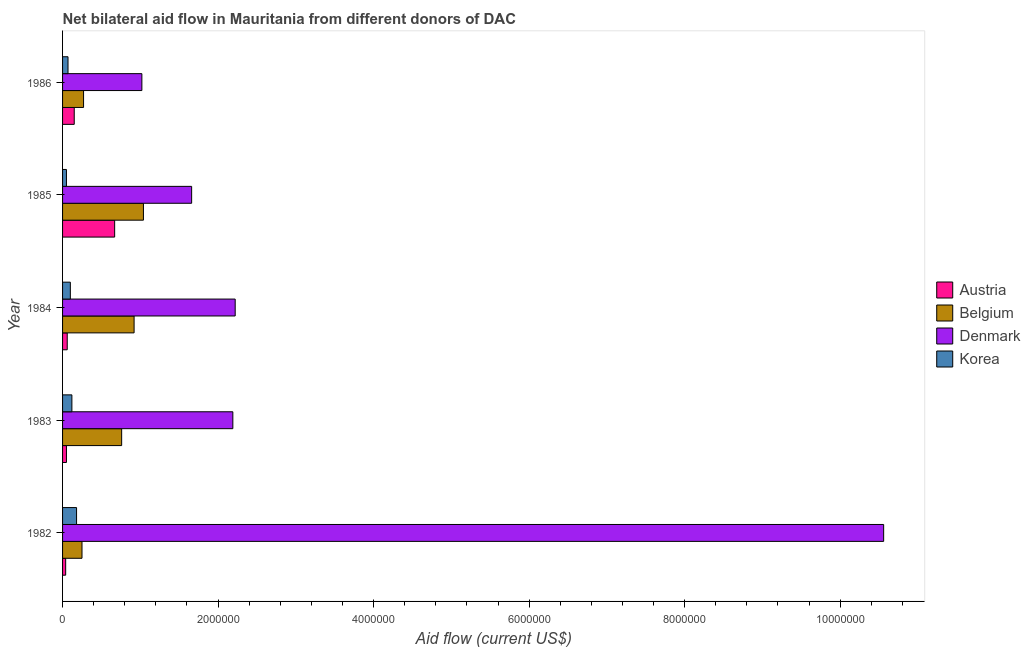Are the number of bars on each tick of the Y-axis equal?
Provide a succinct answer. Yes. How many bars are there on the 4th tick from the bottom?
Make the answer very short. 4. In how many cases, is the number of bars for a given year not equal to the number of legend labels?
Offer a very short reply. 0. What is the amount of aid given by denmark in 1984?
Offer a terse response. 2.22e+06. Across all years, what is the maximum amount of aid given by belgium?
Offer a terse response. 1.04e+06. Across all years, what is the minimum amount of aid given by belgium?
Keep it short and to the point. 2.50e+05. What is the total amount of aid given by denmark in the graph?
Ensure brevity in your answer.  1.76e+07. What is the difference between the amount of aid given by korea in 1984 and that in 1986?
Offer a very short reply. 3.00e+04. What is the difference between the amount of aid given by austria in 1984 and the amount of aid given by korea in 1986?
Provide a succinct answer. -10000. What is the average amount of aid given by denmark per year?
Your response must be concise. 3.53e+06. In the year 1983, what is the difference between the amount of aid given by korea and amount of aid given by denmark?
Provide a succinct answer. -2.07e+06. What is the ratio of the amount of aid given by denmark in 1985 to that in 1986?
Give a very brief answer. 1.63. Is the difference between the amount of aid given by belgium in 1985 and 1986 greater than the difference between the amount of aid given by austria in 1985 and 1986?
Provide a short and direct response. Yes. What is the difference between the highest and the second highest amount of aid given by denmark?
Ensure brevity in your answer.  8.34e+06. What is the difference between the highest and the lowest amount of aid given by denmark?
Make the answer very short. 9.54e+06. In how many years, is the amount of aid given by denmark greater than the average amount of aid given by denmark taken over all years?
Offer a very short reply. 1. Is the sum of the amount of aid given by denmark in 1984 and 1986 greater than the maximum amount of aid given by korea across all years?
Offer a very short reply. Yes. Is it the case that in every year, the sum of the amount of aid given by denmark and amount of aid given by belgium is greater than the sum of amount of aid given by korea and amount of aid given by austria?
Make the answer very short. Yes. What does the 4th bar from the top in 1983 represents?
Offer a very short reply. Austria. Is it the case that in every year, the sum of the amount of aid given by austria and amount of aid given by belgium is greater than the amount of aid given by denmark?
Keep it short and to the point. No. Are all the bars in the graph horizontal?
Your answer should be compact. Yes. Does the graph contain grids?
Your response must be concise. No. Where does the legend appear in the graph?
Your answer should be compact. Center right. How are the legend labels stacked?
Provide a short and direct response. Vertical. What is the title of the graph?
Your response must be concise. Net bilateral aid flow in Mauritania from different donors of DAC. What is the label or title of the Y-axis?
Your response must be concise. Year. What is the Aid flow (current US$) of Austria in 1982?
Ensure brevity in your answer.  4.00e+04. What is the Aid flow (current US$) of Belgium in 1982?
Offer a very short reply. 2.50e+05. What is the Aid flow (current US$) in Denmark in 1982?
Keep it short and to the point. 1.06e+07. What is the Aid flow (current US$) in Korea in 1982?
Provide a succinct answer. 1.80e+05. What is the Aid flow (current US$) in Belgium in 1983?
Give a very brief answer. 7.60e+05. What is the Aid flow (current US$) in Denmark in 1983?
Offer a very short reply. 2.19e+06. What is the Aid flow (current US$) in Korea in 1983?
Provide a short and direct response. 1.20e+05. What is the Aid flow (current US$) in Belgium in 1984?
Keep it short and to the point. 9.20e+05. What is the Aid flow (current US$) of Denmark in 1984?
Give a very brief answer. 2.22e+06. What is the Aid flow (current US$) in Austria in 1985?
Keep it short and to the point. 6.70e+05. What is the Aid flow (current US$) in Belgium in 1985?
Provide a short and direct response. 1.04e+06. What is the Aid flow (current US$) in Denmark in 1985?
Your answer should be very brief. 1.66e+06. What is the Aid flow (current US$) of Korea in 1985?
Your answer should be compact. 5.00e+04. What is the Aid flow (current US$) in Denmark in 1986?
Give a very brief answer. 1.02e+06. What is the Aid flow (current US$) in Korea in 1986?
Provide a succinct answer. 7.00e+04. Across all years, what is the maximum Aid flow (current US$) of Austria?
Your response must be concise. 6.70e+05. Across all years, what is the maximum Aid flow (current US$) of Belgium?
Your answer should be compact. 1.04e+06. Across all years, what is the maximum Aid flow (current US$) in Denmark?
Your answer should be very brief. 1.06e+07. Across all years, what is the maximum Aid flow (current US$) in Korea?
Offer a terse response. 1.80e+05. Across all years, what is the minimum Aid flow (current US$) in Belgium?
Offer a very short reply. 2.50e+05. Across all years, what is the minimum Aid flow (current US$) of Denmark?
Your answer should be compact. 1.02e+06. Across all years, what is the minimum Aid flow (current US$) of Korea?
Offer a very short reply. 5.00e+04. What is the total Aid flow (current US$) in Austria in the graph?
Provide a succinct answer. 9.70e+05. What is the total Aid flow (current US$) of Belgium in the graph?
Offer a very short reply. 3.24e+06. What is the total Aid flow (current US$) in Denmark in the graph?
Provide a short and direct response. 1.76e+07. What is the total Aid flow (current US$) of Korea in the graph?
Provide a succinct answer. 5.20e+05. What is the difference between the Aid flow (current US$) in Belgium in 1982 and that in 1983?
Give a very brief answer. -5.10e+05. What is the difference between the Aid flow (current US$) in Denmark in 1982 and that in 1983?
Provide a short and direct response. 8.37e+06. What is the difference between the Aid flow (current US$) in Korea in 1982 and that in 1983?
Give a very brief answer. 6.00e+04. What is the difference between the Aid flow (current US$) of Belgium in 1982 and that in 1984?
Keep it short and to the point. -6.70e+05. What is the difference between the Aid flow (current US$) in Denmark in 1982 and that in 1984?
Provide a short and direct response. 8.34e+06. What is the difference between the Aid flow (current US$) of Korea in 1982 and that in 1984?
Your answer should be compact. 8.00e+04. What is the difference between the Aid flow (current US$) in Austria in 1982 and that in 1985?
Keep it short and to the point. -6.30e+05. What is the difference between the Aid flow (current US$) in Belgium in 1982 and that in 1985?
Provide a short and direct response. -7.90e+05. What is the difference between the Aid flow (current US$) in Denmark in 1982 and that in 1985?
Offer a very short reply. 8.90e+06. What is the difference between the Aid flow (current US$) in Korea in 1982 and that in 1985?
Ensure brevity in your answer.  1.30e+05. What is the difference between the Aid flow (current US$) in Austria in 1982 and that in 1986?
Give a very brief answer. -1.10e+05. What is the difference between the Aid flow (current US$) of Denmark in 1982 and that in 1986?
Your answer should be very brief. 9.54e+06. What is the difference between the Aid flow (current US$) of Korea in 1982 and that in 1986?
Your answer should be very brief. 1.10e+05. What is the difference between the Aid flow (current US$) of Denmark in 1983 and that in 1984?
Provide a succinct answer. -3.00e+04. What is the difference between the Aid flow (current US$) in Austria in 1983 and that in 1985?
Provide a short and direct response. -6.20e+05. What is the difference between the Aid flow (current US$) in Belgium in 1983 and that in 1985?
Offer a terse response. -2.80e+05. What is the difference between the Aid flow (current US$) of Denmark in 1983 and that in 1985?
Your answer should be compact. 5.30e+05. What is the difference between the Aid flow (current US$) of Belgium in 1983 and that in 1986?
Your answer should be very brief. 4.90e+05. What is the difference between the Aid flow (current US$) in Denmark in 1983 and that in 1986?
Offer a very short reply. 1.17e+06. What is the difference between the Aid flow (current US$) in Austria in 1984 and that in 1985?
Give a very brief answer. -6.10e+05. What is the difference between the Aid flow (current US$) of Denmark in 1984 and that in 1985?
Your response must be concise. 5.60e+05. What is the difference between the Aid flow (current US$) of Austria in 1984 and that in 1986?
Your response must be concise. -9.00e+04. What is the difference between the Aid flow (current US$) of Belgium in 1984 and that in 1986?
Your answer should be compact. 6.50e+05. What is the difference between the Aid flow (current US$) in Denmark in 1984 and that in 1986?
Provide a short and direct response. 1.20e+06. What is the difference between the Aid flow (current US$) of Korea in 1984 and that in 1986?
Make the answer very short. 3.00e+04. What is the difference between the Aid flow (current US$) of Austria in 1985 and that in 1986?
Provide a succinct answer. 5.20e+05. What is the difference between the Aid flow (current US$) in Belgium in 1985 and that in 1986?
Make the answer very short. 7.70e+05. What is the difference between the Aid flow (current US$) in Denmark in 1985 and that in 1986?
Offer a very short reply. 6.40e+05. What is the difference between the Aid flow (current US$) of Korea in 1985 and that in 1986?
Your answer should be compact. -2.00e+04. What is the difference between the Aid flow (current US$) in Austria in 1982 and the Aid flow (current US$) in Belgium in 1983?
Your answer should be compact. -7.20e+05. What is the difference between the Aid flow (current US$) of Austria in 1982 and the Aid flow (current US$) of Denmark in 1983?
Offer a very short reply. -2.15e+06. What is the difference between the Aid flow (current US$) in Austria in 1982 and the Aid flow (current US$) in Korea in 1983?
Ensure brevity in your answer.  -8.00e+04. What is the difference between the Aid flow (current US$) of Belgium in 1982 and the Aid flow (current US$) of Denmark in 1983?
Keep it short and to the point. -1.94e+06. What is the difference between the Aid flow (current US$) in Belgium in 1982 and the Aid flow (current US$) in Korea in 1983?
Ensure brevity in your answer.  1.30e+05. What is the difference between the Aid flow (current US$) of Denmark in 1982 and the Aid flow (current US$) of Korea in 1983?
Ensure brevity in your answer.  1.04e+07. What is the difference between the Aid flow (current US$) in Austria in 1982 and the Aid flow (current US$) in Belgium in 1984?
Your answer should be compact. -8.80e+05. What is the difference between the Aid flow (current US$) in Austria in 1982 and the Aid flow (current US$) in Denmark in 1984?
Your answer should be very brief. -2.18e+06. What is the difference between the Aid flow (current US$) of Austria in 1982 and the Aid flow (current US$) of Korea in 1984?
Make the answer very short. -6.00e+04. What is the difference between the Aid flow (current US$) in Belgium in 1982 and the Aid flow (current US$) in Denmark in 1984?
Your response must be concise. -1.97e+06. What is the difference between the Aid flow (current US$) in Belgium in 1982 and the Aid flow (current US$) in Korea in 1984?
Provide a short and direct response. 1.50e+05. What is the difference between the Aid flow (current US$) of Denmark in 1982 and the Aid flow (current US$) of Korea in 1984?
Ensure brevity in your answer.  1.05e+07. What is the difference between the Aid flow (current US$) in Austria in 1982 and the Aid flow (current US$) in Denmark in 1985?
Give a very brief answer. -1.62e+06. What is the difference between the Aid flow (current US$) in Austria in 1982 and the Aid flow (current US$) in Korea in 1985?
Provide a succinct answer. -10000. What is the difference between the Aid flow (current US$) of Belgium in 1982 and the Aid flow (current US$) of Denmark in 1985?
Your answer should be very brief. -1.41e+06. What is the difference between the Aid flow (current US$) of Denmark in 1982 and the Aid flow (current US$) of Korea in 1985?
Your answer should be very brief. 1.05e+07. What is the difference between the Aid flow (current US$) in Austria in 1982 and the Aid flow (current US$) in Denmark in 1986?
Keep it short and to the point. -9.80e+05. What is the difference between the Aid flow (current US$) of Austria in 1982 and the Aid flow (current US$) of Korea in 1986?
Your answer should be compact. -3.00e+04. What is the difference between the Aid flow (current US$) in Belgium in 1982 and the Aid flow (current US$) in Denmark in 1986?
Give a very brief answer. -7.70e+05. What is the difference between the Aid flow (current US$) in Denmark in 1982 and the Aid flow (current US$) in Korea in 1986?
Provide a short and direct response. 1.05e+07. What is the difference between the Aid flow (current US$) of Austria in 1983 and the Aid flow (current US$) of Belgium in 1984?
Keep it short and to the point. -8.70e+05. What is the difference between the Aid flow (current US$) of Austria in 1983 and the Aid flow (current US$) of Denmark in 1984?
Your answer should be very brief. -2.17e+06. What is the difference between the Aid flow (current US$) of Belgium in 1983 and the Aid flow (current US$) of Denmark in 1984?
Offer a very short reply. -1.46e+06. What is the difference between the Aid flow (current US$) of Belgium in 1983 and the Aid flow (current US$) of Korea in 1984?
Your answer should be compact. 6.60e+05. What is the difference between the Aid flow (current US$) in Denmark in 1983 and the Aid flow (current US$) in Korea in 1984?
Your answer should be very brief. 2.09e+06. What is the difference between the Aid flow (current US$) of Austria in 1983 and the Aid flow (current US$) of Belgium in 1985?
Your response must be concise. -9.90e+05. What is the difference between the Aid flow (current US$) in Austria in 1983 and the Aid flow (current US$) in Denmark in 1985?
Offer a very short reply. -1.61e+06. What is the difference between the Aid flow (current US$) of Austria in 1983 and the Aid flow (current US$) of Korea in 1985?
Your response must be concise. 0. What is the difference between the Aid flow (current US$) of Belgium in 1983 and the Aid flow (current US$) of Denmark in 1985?
Give a very brief answer. -9.00e+05. What is the difference between the Aid flow (current US$) of Belgium in 1983 and the Aid flow (current US$) of Korea in 1985?
Keep it short and to the point. 7.10e+05. What is the difference between the Aid flow (current US$) in Denmark in 1983 and the Aid flow (current US$) in Korea in 1985?
Provide a succinct answer. 2.14e+06. What is the difference between the Aid flow (current US$) of Austria in 1983 and the Aid flow (current US$) of Denmark in 1986?
Provide a succinct answer. -9.70e+05. What is the difference between the Aid flow (current US$) of Belgium in 1983 and the Aid flow (current US$) of Korea in 1986?
Your answer should be very brief. 6.90e+05. What is the difference between the Aid flow (current US$) of Denmark in 1983 and the Aid flow (current US$) of Korea in 1986?
Ensure brevity in your answer.  2.12e+06. What is the difference between the Aid flow (current US$) of Austria in 1984 and the Aid flow (current US$) of Belgium in 1985?
Ensure brevity in your answer.  -9.80e+05. What is the difference between the Aid flow (current US$) in Austria in 1984 and the Aid flow (current US$) in Denmark in 1985?
Make the answer very short. -1.60e+06. What is the difference between the Aid flow (current US$) of Belgium in 1984 and the Aid flow (current US$) of Denmark in 1985?
Offer a terse response. -7.40e+05. What is the difference between the Aid flow (current US$) in Belgium in 1984 and the Aid flow (current US$) in Korea in 1985?
Offer a terse response. 8.70e+05. What is the difference between the Aid flow (current US$) of Denmark in 1984 and the Aid flow (current US$) of Korea in 1985?
Your answer should be very brief. 2.17e+06. What is the difference between the Aid flow (current US$) of Austria in 1984 and the Aid flow (current US$) of Belgium in 1986?
Provide a short and direct response. -2.10e+05. What is the difference between the Aid flow (current US$) in Austria in 1984 and the Aid flow (current US$) in Denmark in 1986?
Your answer should be very brief. -9.60e+05. What is the difference between the Aid flow (current US$) in Belgium in 1984 and the Aid flow (current US$) in Korea in 1986?
Your response must be concise. 8.50e+05. What is the difference between the Aid flow (current US$) in Denmark in 1984 and the Aid flow (current US$) in Korea in 1986?
Offer a very short reply. 2.15e+06. What is the difference between the Aid flow (current US$) in Austria in 1985 and the Aid flow (current US$) in Belgium in 1986?
Offer a very short reply. 4.00e+05. What is the difference between the Aid flow (current US$) in Austria in 1985 and the Aid flow (current US$) in Denmark in 1986?
Provide a succinct answer. -3.50e+05. What is the difference between the Aid flow (current US$) in Belgium in 1985 and the Aid flow (current US$) in Denmark in 1986?
Make the answer very short. 2.00e+04. What is the difference between the Aid flow (current US$) of Belgium in 1985 and the Aid flow (current US$) of Korea in 1986?
Make the answer very short. 9.70e+05. What is the difference between the Aid flow (current US$) in Denmark in 1985 and the Aid flow (current US$) in Korea in 1986?
Provide a short and direct response. 1.59e+06. What is the average Aid flow (current US$) in Austria per year?
Keep it short and to the point. 1.94e+05. What is the average Aid flow (current US$) of Belgium per year?
Your response must be concise. 6.48e+05. What is the average Aid flow (current US$) in Denmark per year?
Provide a succinct answer. 3.53e+06. What is the average Aid flow (current US$) of Korea per year?
Make the answer very short. 1.04e+05. In the year 1982, what is the difference between the Aid flow (current US$) of Austria and Aid flow (current US$) of Belgium?
Give a very brief answer. -2.10e+05. In the year 1982, what is the difference between the Aid flow (current US$) of Austria and Aid flow (current US$) of Denmark?
Make the answer very short. -1.05e+07. In the year 1982, what is the difference between the Aid flow (current US$) in Belgium and Aid flow (current US$) in Denmark?
Your answer should be compact. -1.03e+07. In the year 1982, what is the difference between the Aid flow (current US$) of Belgium and Aid flow (current US$) of Korea?
Your answer should be very brief. 7.00e+04. In the year 1982, what is the difference between the Aid flow (current US$) in Denmark and Aid flow (current US$) in Korea?
Provide a short and direct response. 1.04e+07. In the year 1983, what is the difference between the Aid flow (current US$) of Austria and Aid flow (current US$) of Belgium?
Ensure brevity in your answer.  -7.10e+05. In the year 1983, what is the difference between the Aid flow (current US$) of Austria and Aid flow (current US$) of Denmark?
Make the answer very short. -2.14e+06. In the year 1983, what is the difference between the Aid flow (current US$) in Belgium and Aid flow (current US$) in Denmark?
Make the answer very short. -1.43e+06. In the year 1983, what is the difference between the Aid flow (current US$) in Belgium and Aid flow (current US$) in Korea?
Offer a very short reply. 6.40e+05. In the year 1983, what is the difference between the Aid flow (current US$) of Denmark and Aid flow (current US$) of Korea?
Provide a succinct answer. 2.07e+06. In the year 1984, what is the difference between the Aid flow (current US$) in Austria and Aid flow (current US$) in Belgium?
Your answer should be compact. -8.60e+05. In the year 1984, what is the difference between the Aid flow (current US$) of Austria and Aid flow (current US$) of Denmark?
Your response must be concise. -2.16e+06. In the year 1984, what is the difference between the Aid flow (current US$) of Belgium and Aid flow (current US$) of Denmark?
Provide a succinct answer. -1.30e+06. In the year 1984, what is the difference between the Aid flow (current US$) of Belgium and Aid flow (current US$) of Korea?
Your answer should be very brief. 8.20e+05. In the year 1984, what is the difference between the Aid flow (current US$) in Denmark and Aid flow (current US$) in Korea?
Your response must be concise. 2.12e+06. In the year 1985, what is the difference between the Aid flow (current US$) in Austria and Aid flow (current US$) in Belgium?
Ensure brevity in your answer.  -3.70e+05. In the year 1985, what is the difference between the Aid flow (current US$) in Austria and Aid flow (current US$) in Denmark?
Ensure brevity in your answer.  -9.90e+05. In the year 1985, what is the difference between the Aid flow (current US$) of Austria and Aid flow (current US$) of Korea?
Ensure brevity in your answer.  6.20e+05. In the year 1985, what is the difference between the Aid flow (current US$) of Belgium and Aid flow (current US$) of Denmark?
Your response must be concise. -6.20e+05. In the year 1985, what is the difference between the Aid flow (current US$) of Belgium and Aid flow (current US$) of Korea?
Your response must be concise. 9.90e+05. In the year 1985, what is the difference between the Aid flow (current US$) of Denmark and Aid flow (current US$) of Korea?
Keep it short and to the point. 1.61e+06. In the year 1986, what is the difference between the Aid flow (current US$) of Austria and Aid flow (current US$) of Denmark?
Provide a short and direct response. -8.70e+05. In the year 1986, what is the difference between the Aid flow (current US$) of Austria and Aid flow (current US$) of Korea?
Make the answer very short. 8.00e+04. In the year 1986, what is the difference between the Aid flow (current US$) of Belgium and Aid flow (current US$) of Denmark?
Your answer should be very brief. -7.50e+05. In the year 1986, what is the difference between the Aid flow (current US$) in Belgium and Aid flow (current US$) in Korea?
Make the answer very short. 2.00e+05. In the year 1986, what is the difference between the Aid flow (current US$) in Denmark and Aid flow (current US$) in Korea?
Make the answer very short. 9.50e+05. What is the ratio of the Aid flow (current US$) in Austria in 1982 to that in 1983?
Make the answer very short. 0.8. What is the ratio of the Aid flow (current US$) in Belgium in 1982 to that in 1983?
Your answer should be very brief. 0.33. What is the ratio of the Aid flow (current US$) in Denmark in 1982 to that in 1983?
Your answer should be very brief. 4.82. What is the ratio of the Aid flow (current US$) in Austria in 1982 to that in 1984?
Offer a terse response. 0.67. What is the ratio of the Aid flow (current US$) of Belgium in 1982 to that in 1984?
Provide a succinct answer. 0.27. What is the ratio of the Aid flow (current US$) in Denmark in 1982 to that in 1984?
Make the answer very short. 4.76. What is the ratio of the Aid flow (current US$) in Korea in 1982 to that in 1984?
Provide a succinct answer. 1.8. What is the ratio of the Aid flow (current US$) of Austria in 1982 to that in 1985?
Your answer should be very brief. 0.06. What is the ratio of the Aid flow (current US$) in Belgium in 1982 to that in 1985?
Offer a very short reply. 0.24. What is the ratio of the Aid flow (current US$) in Denmark in 1982 to that in 1985?
Your response must be concise. 6.36. What is the ratio of the Aid flow (current US$) of Korea in 1982 to that in 1985?
Ensure brevity in your answer.  3.6. What is the ratio of the Aid flow (current US$) in Austria in 1982 to that in 1986?
Your response must be concise. 0.27. What is the ratio of the Aid flow (current US$) of Belgium in 1982 to that in 1986?
Make the answer very short. 0.93. What is the ratio of the Aid flow (current US$) in Denmark in 1982 to that in 1986?
Your answer should be very brief. 10.35. What is the ratio of the Aid flow (current US$) of Korea in 1982 to that in 1986?
Offer a terse response. 2.57. What is the ratio of the Aid flow (current US$) in Austria in 1983 to that in 1984?
Provide a succinct answer. 0.83. What is the ratio of the Aid flow (current US$) of Belgium in 1983 to that in 1984?
Provide a short and direct response. 0.83. What is the ratio of the Aid flow (current US$) of Denmark in 1983 to that in 1984?
Make the answer very short. 0.99. What is the ratio of the Aid flow (current US$) in Korea in 1983 to that in 1984?
Keep it short and to the point. 1.2. What is the ratio of the Aid flow (current US$) in Austria in 1983 to that in 1985?
Provide a succinct answer. 0.07. What is the ratio of the Aid flow (current US$) of Belgium in 1983 to that in 1985?
Give a very brief answer. 0.73. What is the ratio of the Aid flow (current US$) of Denmark in 1983 to that in 1985?
Your answer should be compact. 1.32. What is the ratio of the Aid flow (current US$) in Korea in 1983 to that in 1985?
Your answer should be compact. 2.4. What is the ratio of the Aid flow (current US$) of Austria in 1983 to that in 1986?
Keep it short and to the point. 0.33. What is the ratio of the Aid flow (current US$) in Belgium in 1983 to that in 1986?
Your response must be concise. 2.81. What is the ratio of the Aid flow (current US$) of Denmark in 1983 to that in 1986?
Provide a succinct answer. 2.15. What is the ratio of the Aid flow (current US$) in Korea in 1983 to that in 1986?
Your answer should be very brief. 1.71. What is the ratio of the Aid flow (current US$) of Austria in 1984 to that in 1985?
Provide a succinct answer. 0.09. What is the ratio of the Aid flow (current US$) of Belgium in 1984 to that in 1985?
Your response must be concise. 0.88. What is the ratio of the Aid flow (current US$) of Denmark in 1984 to that in 1985?
Make the answer very short. 1.34. What is the ratio of the Aid flow (current US$) in Korea in 1984 to that in 1985?
Your answer should be compact. 2. What is the ratio of the Aid flow (current US$) of Belgium in 1984 to that in 1986?
Your answer should be compact. 3.41. What is the ratio of the Aid flow (current US$) of Denmark in 1984 to that in 1986?
Keep it short and to the point. 2.18. What is the ratio of the Aid flow (current US$) of Korea in 1984 to that in 1986?
Make the answer very short. 1.43. What is the ratio of the Aid flow (current US$) in Austria in 1985 to that in 1986?
Offer a terse response. 4.47. What is the ratio of the Aid flow (current US$) in Belgium in 1985 to that in 1986?
Provide a short and direct response. 3.85. What is the ratio of the Aid flow (current US$) in Denmark in 1985 to that in 1986?
Keep it short and to the point. 1.63. What is the ratio of the Aid flow (current US$) in Korea in 1985 to that in 1986?
Provide a succinct answer. 0.71. What is the difference between the highest and the second highest Aid flow (current US$) of Austria?
Make the answer very short. 5.20e+05. What is the difference between the highest and the second highest Aid flow (current US$) of Denmark?
Provide a succinct answer. 8.34e+06. What is the difference between the highest and the lowest Aid flow (current US$) in Austria?
Make the answer very short. 6.30e+05. What is the difference between the highest and the lowest Aid flow (current US$) in Belgium?
Give a very brief answer. 7.90e+05. What is the difference between the highest and the lowest Aid flow (current US$) of Denmark?
Provide a short and direct response. 9.54e+06. 